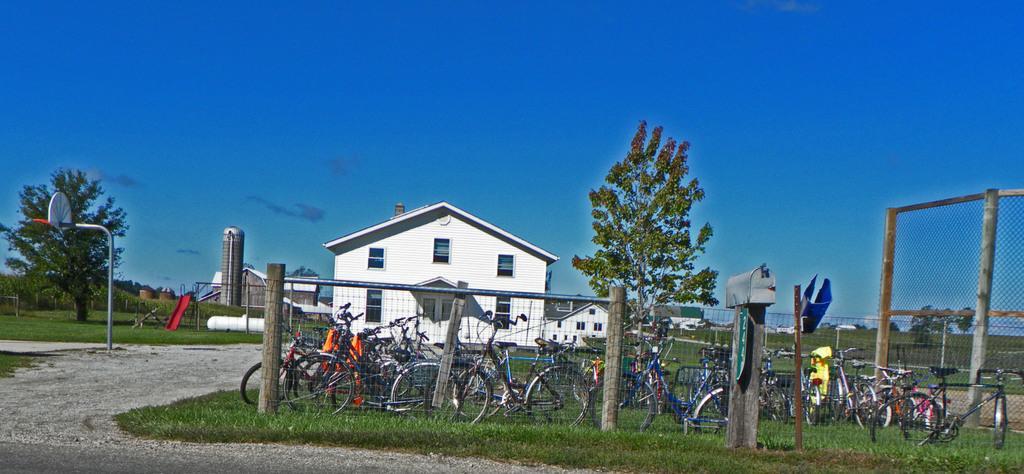Can you describe this image briefly? There is a fencing with poles. On the ground there is grass. In the back there are cycles, tree and a building with windows and doors. In the background there are buildings, trees, poles and sky. Also there is a road. 